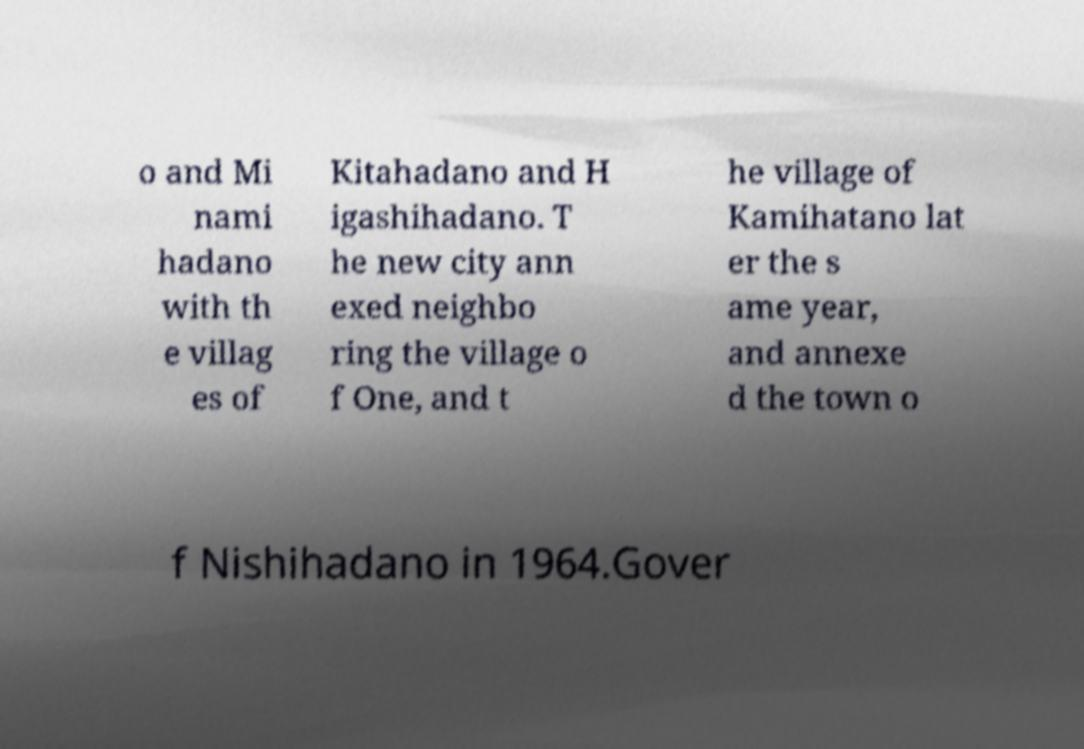Can you accurately transcribe the text from the provided image for me? o and Mi nami hadano with th e villag es of Kitahadano and H igashihadano. T he new city ann exed neighbo ring the village o f One, and t he village of Kamihatano lat er the s ame year, and annexe d the town o f Nishihadano in 1964.Gover 